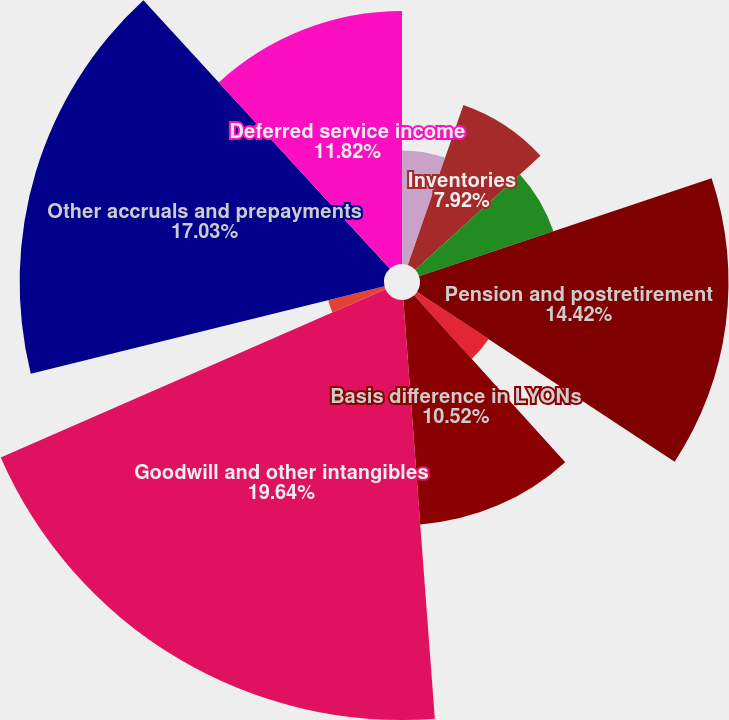<chart> <loc_0><loc_0><loc_500><loc_500><pie_chart><fcel>Bad debt allowance<fcel>Inventories<fcel>Property plant and equipment<fcel>Pension and postretirement<fcel>Insurance including self -<fcel>Basis difference in LYONs<fcel>Goodwill and other intangibles<fcel>Environmental and regulatory<fcel>Other accruals and prepayments<fcel>Deferred service income<nl><fcel>5.31%<fcel>7.92%<fcel>6.62%<fcel>14.42%<fcel>4.01%<fcel>10.52%<fcel>19.63%<fcel>2.71%<fcel>17.03%<fcel>11.82%<nl></chart> 